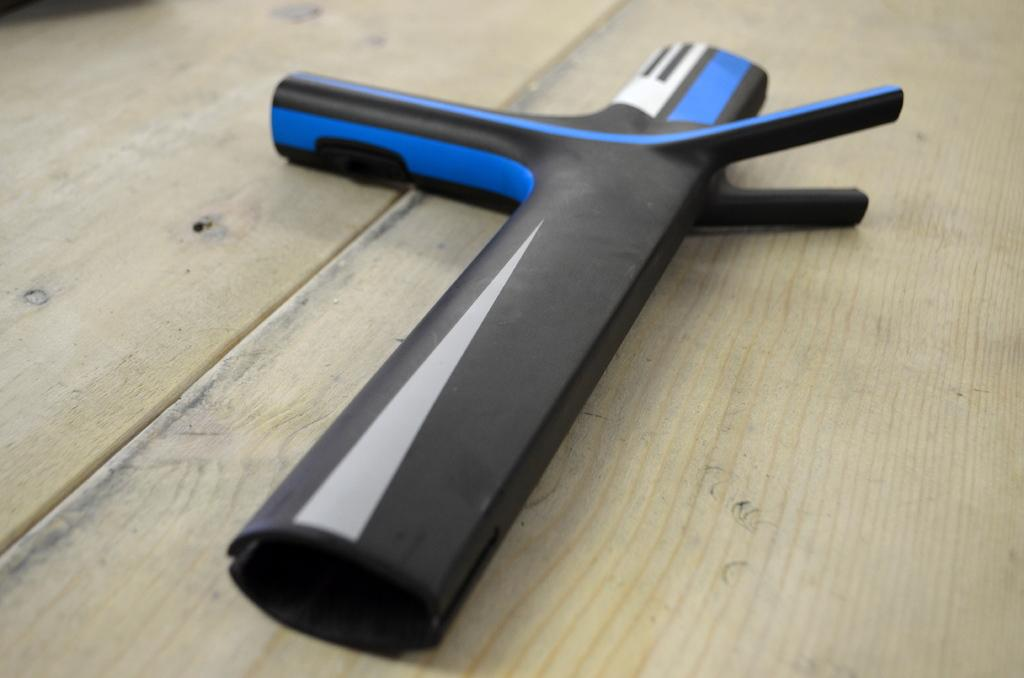What is the color of the object that is visible in the image? The object in the image is black. Where is the black object placed in the image? The black object is placed on top of a wooden object, which seems to be a table. What type of breakfast is being prepared on the table in the image? There is no breakfast or any indication of food preparation in the image; it only shows a black object placed on a wooden table. 